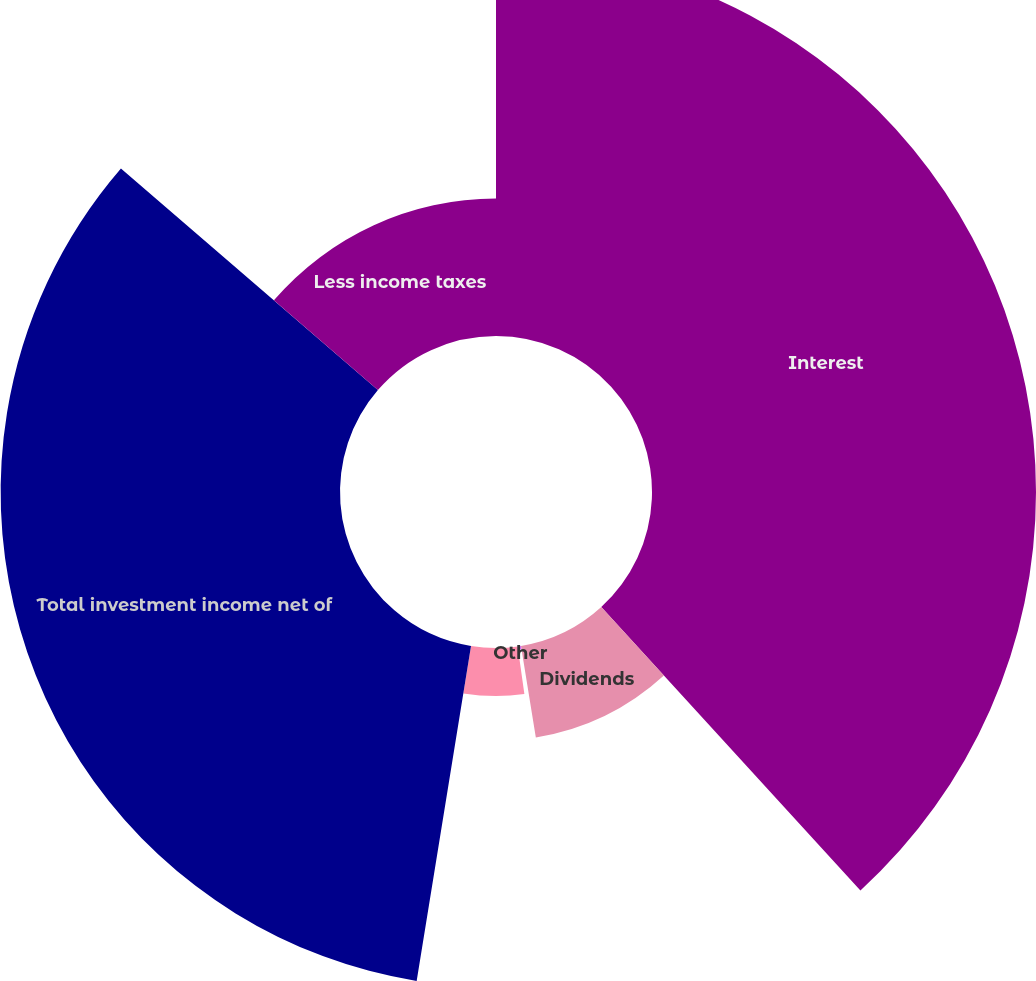Convert chart to OTSL. <chart><loc_0><loc_0><loc_500><loc_500><pie_chart><fcel>Interest<fcel>Dividends<fcel>Other<fcel>Less investment expenses<fcel>Total investment income net of<fcel>Less income taxes<nl><fcel>38.21%<fcel>9.23%<fcel>0.34%<fcel>4.78%<fcel>33.77%<fcel>13.67%<nl></chart> 